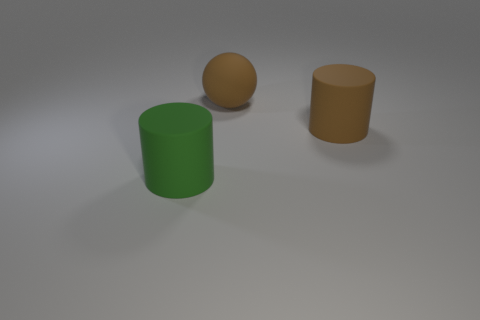Add 1 brown matte things. How many objects exist? 4 Subtract all cylinders. How many objects are left? 1 Add 1 large rubber spheres. How many large rubber spheres exist? 2 Subtract 1 brown cylinders. How many objects are left? 2 Subtract all large rubber balls. Subtract all big gray cylinders. How many objects are left? 2 Add 1 green rubber things. How many green rubber things are left? 2 